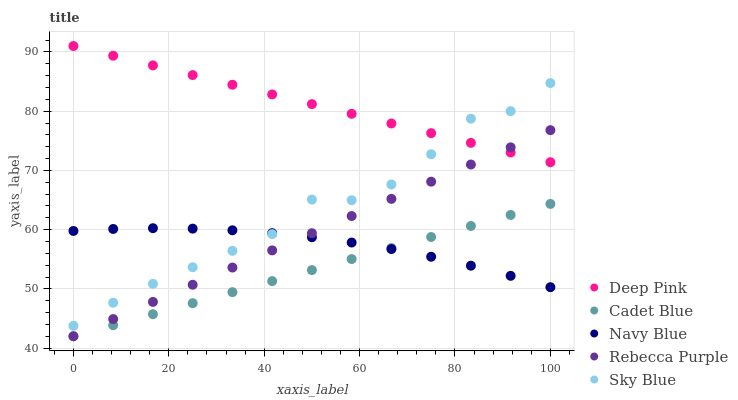Does Cadet Blue have the minimum area under the curve?
Answer yes or no. Yes. Does Deep Pink have the maximum area under the curve?
Answer yes or no. Yes. Does Navy Blue have the minimum area under the curve?
Answer yes or no. No. Does Navy Blue have the maximum area under the curve?
Answer yes or no. No. Is Deep Pink the smoothest?
Answer yes or no. Yes. Is Sky Blue the roughest?
Answer yes or no. Yes. Is Navy Blue the smoothest?
Answer yes or no. No. Is Navy Blue the roughest?
Answer yes or no. No. Does Cadet Blue have the lowest value?
Answer yes or no. Yes. Does Navy Blue have the lowest value?
Answer yes or no. No. Does Deep Pink have the highest value?
Answer yes or no. Yes. Does Navy Blue have the highest value?
Answer yes or no. No. Is Navy Blue less than Deep Pink?
Answer yes or no. Yes. Is Sky Blue greater than Rebecca Purple?
Answer yes or no. Yes. Does Rebecca Purple intersect Cadet Blue?
Answer yes or no. Yes. Is Rebecca Purple less than Cadet Blue?
Answer yes or no. No. Is Rebecca Purple greater than Cadet Blue?
Answer yes or no. No. Does Navy Blue intersect Deep Pink?
Answer yes or no. No. 